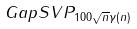<formula> <loc_0><loc_0><loc_500><loc_500>G a p S V P _ { 1 0 0 \sqrt { n } \gamma ( n ) }</formula> 